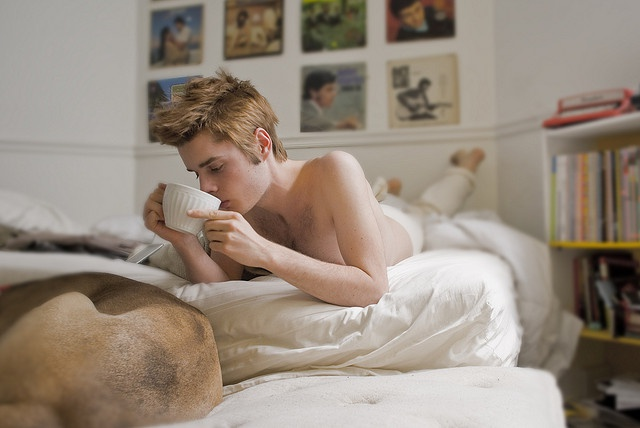Describe the objects in this image and their specific colors. I can see people in darkgray, gray, maroon, and tan tones, dog in darkgray, gray, and tan tones, bed in darkgray, lightgray, and gray tones, people in darkgray, gray, black, and maroon tones, and book in darkgray, black, and gray tones in this image. 